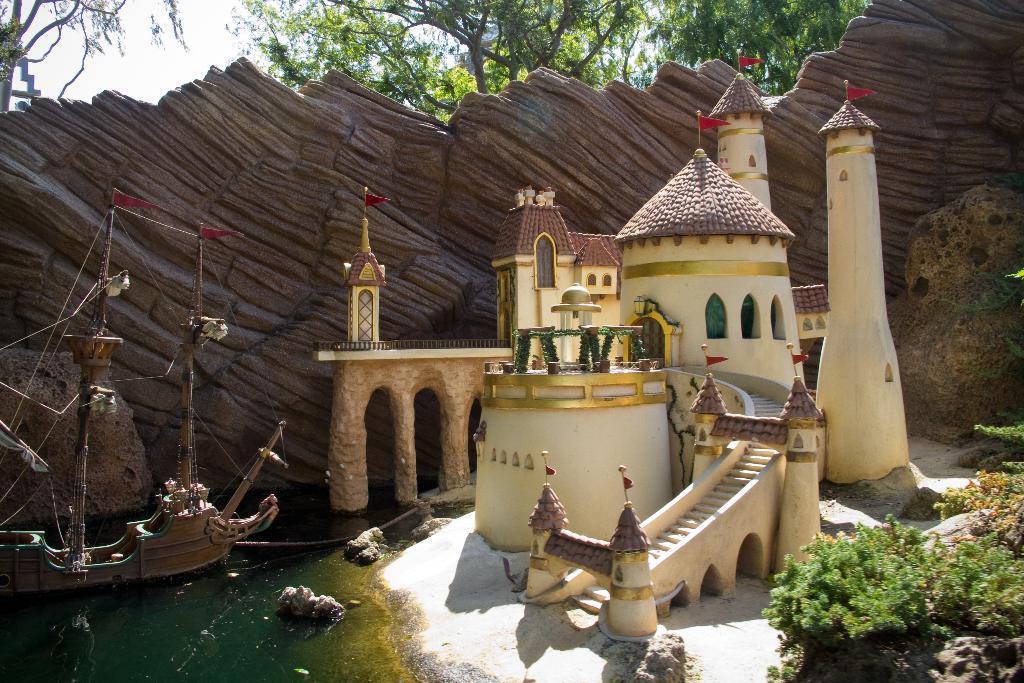In one or two sentences, can you explain what this image depicts? In this picture, there is a miniature art. In the center, there is a castle. Before it, there is a ship in the water. At the bottom right, there are trees. On the top, there are trees and sky. 